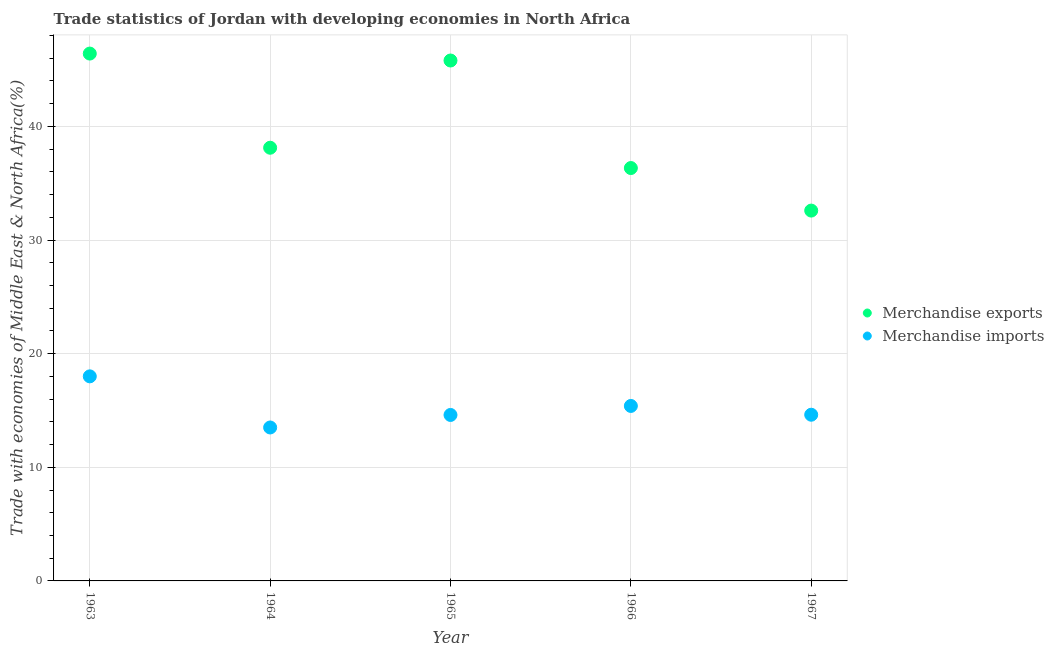How many different coloured dotlines are there?
Your answer should be compact. 2. What is the merchandise imports in 1963?
Provide a succinct answer. 18. Across all years, what is the maximum merchandise imports?
Make the answer very short. 18. Across all years, what is the minimum merchandise imports?
Offer a very short reply. 13.5. In which year was the merchandise imports minimum?
Provide a succinct answer. 1964. What is the total merchandise exports in the graph?
Your answer should be very brief. 199.24. What is the difference between the merchandise exports in 1965 and that in 1967?
Provide a short and direct response. 13.21. What is the difference between the merchandise exports in 1965 and the merchandise imports in 1967?
Make the answer very short. 31.17. What is the average merchandise imports per year?
Offer a very short reply. 15.23. In the year 1963, what is the difference between the merchandise imports and merchandise exports?
Provide a short and direct response. -28.4. In how many years, is the merchandise imports greater than 22 %?
Your answer should be compact. 0. What is the ratio of the merchandise exports in 1963 to that in 1967?
Your response must be concise. 1.42. What is the difference between the highest and the second highest merchandise exports?
Ensure brevity in your answer.  0.61. What is the difference between the highest and the lowest merchandise exports?
Offer a terse response. 13.82. Is the merchandise imports strictly greater than the merchandise exports over the years?
Offer a terse response. No. What is the difference between two consecutive major ticks on the Y-axis?
Ensure brevity in your answer.  10. Are the values on the major ticks of Y-axis written in scientific E-notation?
Ensure brevity in your answer.  No. Does the graph contain grids?
Offer a very short reply. Yes. How are the legend labels stacked?
Your response must be concise. Vertical. What is the title of the graph?
Keep it short and to the point. Trade statistics of Jordan with developing economies in North Africa. Does "Males" appear as one of the legend labels in the graph?
Your response must be concise. No. What is the label or title of the X-axis?
Give a very brief answer. Year. What is the label or title of the Y-axis?
Make the answer very short. Trade with economies of Middle East & North Africa(%). What is the Trade with economies of Middle East & North Africa(%) in Merchandise exports in 1963?
Your answer should be very brief. 46.41. What is the Trade with economies of Middle East & North Africa(%) in Merchandise imports in 1963?
Make the answer very short. 18. What is the Trade with economies of Middle East & North Africa(%) in Merchandise exports in 1964?
Make the answer very short. 38.12. What is the Trade with economies of Middle East & North Africa(%) of Merchandise imports in 1964?
Your answer should be compact. 13.5. What is the Trade with economies of Middle East & North Africa(%) of Merchandise exports in 1965?
Keep it short and to the point. 45.79. What is the Trade with economies of Middle East & North Africa(%) in Merchandise imports in 1965?
Offer a terse response. 14.6. What is the Trade with economies of Middle East & North Africa(%) of Merchandise exports in 1966?
Offer a terse response. 36.33. What is the Trade with economies of Middle East & North Africa(%) of Merchandise imports in 1966?
Your answer should be compact. 15.4. What is the Trade with economies of Middle East & North Africa(%) of Merchandise exports in 1967?
Offer a terse response. 32.59. What is the Trade with economies of Middle East & North Africa(%) of Merchandise imports in 1967?
Ensure brevity in your answer.  14.62. Across all years, what is the maximum Trade with economies of Middle East & North Africa(%) of Merchandise exports?
Keep it short and to the point. 46.41. Across all years, what is the maximum Trade with economies of Middle East & North Africa(%) in Merchandise imports?
Provide a short and direct response. 18. Across all years, what is the minimum Trade with economies of Middle East & North Africa(%) of Merchandise exports?
Your answer should be compact. 32.59. Across all years, what is the minimum Trade with economies of Middle East & North Africa(%) of Merchandise imports?
Offer a terse response. 13.5. What is the total Trade with economies of Middle East & North Africa(%) in Merchandise exports in the graph?
Your response must be concise. 199.24. What is the total Trade with economies of Middle East & North Africa(%) of Merchandise imports in the graph?
Keep it short and to the point. 76.13. What is the difference between the Trade with economies of Middle East & North Africa(%) in Merchandise exports in 1963 and that in 1964?
Your response must be concise. 8.29. What is the difference between the Trade with economies of Middle East & North Africa(%) of Merchandise imports in 1963 and that in 1964?
Offer a terse response. 4.5. What is the difference between the Trade with economies of Middle East & North Africa(%) in Merchandise exports in 1963 and that in 1965?
Offer a very short reply. 0.61. What is the difference between the Trade with economies of Middle East & North Africa(%) of Merchandise imports in 1963 and that in 1965?
Give a very brief answer. 3.4. What is the difference between the Trade with economies of Middle East & North Africa(%) in Merchandise exports in 1963 and that in 1966?
Offer a terse response. 10.07. What is the difference between the Trade with economies of Middle East & North Africa(%) of Merchandise imports in 1963 and that in 1966?
Provide a succinct answer. 2.6. What is the difference between the Trade with economies of Middle East & North Africa(%) of Merchandise exports in 1963 and that in 1967?
Your answer should be very brief. 13.82. What is the difference between the Trade with economies of Middle East & North Africa(%) in Merchandise imports in 1963 and that in 1967?
Your answer should be compact. 3.38. What is the difference between the Trade with economies of Middle East & North Africa(%) in Merchandise exports in 1964 and that in 1965?
Keep it short and to the point. -7.68. What is the difference between the Trade with economies of Middle East & North Africa(%) in Merchandise imports in 1964 and that in 1965?
Offer a very short reply. -1.1. What is the difference between the Trade with economies of Middle East & North Africa(%) of Merchandise exports in 1964 and that in 1966?
Your answer should be compact. 1.79. What is the difference between the Trade with economies of Middle East & North Africa(%) of Merchandise imports in 1964 and that in 1966?
Ensure brevity in your answer.  -1.89. What is the difference between the Trade with economies of Middle East & North Africa(%) of Merchandise exports in 1964 and that in 1967?
Make the answer very short. 5.53. What is the difference between the Trade with economies of Middle East & North Africa(%) in Merchandise imports in 1964 and that in 1967?
Make the answer very short. -1.12. What is the difference between the Trade with economies of Middle East & North Africa(%) of Merchandise exports in 1965 and that in 1966?
Provide a short and direct response. 9.46. What is the difference between the Trade with economies of Middle East & North Africa(%) in Merchandise imports in 1965 and that in 1966?
Offer a very short reply. -0.79. What is the difference between the Trade with economies of Middle East & North Africa(%) in Merchandise exports in 1965 and that in 1967?
Make the answer very short. 13.21. What is the difference between the Trade with economies of Middle East & North Africa(%) of Merchandise imports in 1965 and that in 1967?
Your answer should be very brief. -0.02. What is the difference between the Trade with economies of Middle East & North Africa(%) in Merchandise exports in 1966 and that in 1967?
Provide a succinct answer. 3.74. What is the difference between the Trade with economies of Middle East & North Africa(%) in Merchandise imports in 1966 and that in 1967?
Offer a very short reply. 0.77. What is the difference between the Trade with economies of Middle East & North Africa(%) of Merchandise exports in 1963 and the Trade with economies of Middle East & North Africa(%) of Merchandise imports in 1964?
Your response must be concise. 32.9. What is the difference between the Trade with economies of Middle East & North Africa(%) of Merchandise exports in 1963 and the Trade with economies of Middle East & North Africa(%) of Merchandise imports in 1965?
Offer a terse response. 31.8. What is the difference between the Trade with economies of Middle East & North Africa(%) in Merchandise exports in 1963 and the Trade with economies of Middle East & North Africa(%) in Merchandise imports in 1966?
Your answer should be very brief. 31.01. What is the difference between the Trade with economies of Middle East & North Africa(%) of Merchandise exports in 1963 and the Trade with economies of Middle East & North Africa(%) of Merchandise imports in 1967?
Keep it short and to the point. 31.78. What is the difference between the Trade with economies of Middle East & North Africa(%) of Merchandise exports in 1964 and the Trade with economies of Middle East & North Africa(%) of Merchandise imports in 1965?
Your answer should be compact. 23.51. What is the difference between the Trade with economies of Middle East & North Africa(%) in Merchandise exports in 1964 and the Trade with economies of Middle East & North Africa(%) in Merchandise imports in 1966?
Make the answer very short. 22.72. What is the difference between the Trade with economies of Middle East & North Africa(%) in Merchandise exports in 1964 and the Trade with economies of Middle East & North Africa(%) in Merchandise imports in 1967?
Keep it short and to the point. 23.49. What is the difference between the Trade with economies of Middle East & North Africa(%) in Merchandise exports in 1965 and the Trade with economies of Middle East & North Africa(%) in Merchandise imports in 1966?
Keep it short and to the point. 30.4. What is the difference between the Trade with economies of Middle East & North Africa(%) in Merchandise exports in 1965 and the Trade with economies of Middle East & North Africa(%) in Merchandise imports in 1967?
Keep it short and to the point. 31.17. What is the difference between the Trade with economies of Middle East & North Africa(%) in Merchandise exports in 1966 and the Trade with economies of Middle East & North Africa(%) in Merchandise imports in 1967?
Give a very brief answer. 21.71. What is the average Trade with economies of Middle East & North Africa(%) of Merchandise exports per year?
Offer a very short reply. 39.85. What is the average Trade with economies of Middle East & North Africa(%) of Merchandise imports per year?
Your answer should be compact. 15.23. In the year 1963, what is the difference between the Trade with economies of Middle East & North Africa(%) of Merchandise exports and Trade with economies of Middle East & North Africa(%) of Merchandise imports?
Offer a terse response. 28.4. In the year 1964, what is the difference between the Trade with economies of Middle East & North Africa(%) in Merchandise exports and Trade with economies of Middle East & North Africa(%) in Merchandise imports?
Ensure brevity in your answer.  24.62. In the year 1965, what is the difference between the Trade with economies of Middle East & North Africa(%) of Merchandise exports and Trade with economies of Middle East & North Africa(%) of Merchandise imports?
Offer a terse response. 31.19. In the year 1966, what is the difference between the Trade with economies of Middle East & North Africa(%) of Merchandise exports and Trade with economies of Middle East & North Africa(%) of Merchandise imports?
Provide a succinct answer. 20.94. In the year 1967, what is the difference between the Trade with economies of Middle East & North Africa(%) of Merchandise exports and Trade with economies of Middle East & North Africa(%) of Merchandise imports?
Provide a succinct answer. 17.96. What is the ratio of the Trade with economies of Middle East & North Africa(%) of Merchandise exports in 1963 to that in 1964?
Offer a terse response. 1.22. What is the ratio of the Trade with economies of Middle East & North Africa(%) in Merchandise imports in 1963 to that in 1964?
Offer a terse response. 1.33. What is the ratio of the Trade with economies of Middle East & North Africa(%) of Merchandise exports in 1963 to that in 1965?
Your response must be concise. 1.01. What is the ratio of the Trade with economies of Middle East & North Africa(%) of Merchandise imports in 1963 to that in 1965?
Offer a terse response. 1.23. What is the ratio of the Trade with economies of Middle East & North Africa(%) of Merchandise exports in 1963 to that in 1966?
Your response must be concise. 1.28. What is the ratio of the Trade with economies of Middle East & North Africa(%) in Merchandise imports in 1963 to that in 1966?
Ensure brevity in your answer.  1.17. What is the ratio of the Trade with economies of Middle East & North Africa(%) in Merchandise exports in 1963 to that in 1967?
Your response must be concise. 1.42. What is the ratio of the Trade with economies of Middle East & North Africa(%) in Merchandise imports in 1963 to that in 1967?
Make the answer very short. 1.23. What is the ratio of the Trade with economies of Middle East & North Africa(%) of Merchandise exports in 1964 to that in 1965?
Your response must be concise. 0.83. What is the ratio of the Trade with economies of Middle East & North Africa(%) in Merchandise imports in 1964 to that in 1965?
Give a very brief answer. 0.92. What is the ratio of the Trade with economies of Middle East & North Africa(%) of Merchandise exports in 1964 to that in 1966?
Provide a short and direct response. 1.05. What is the ratio of the Trade with economies of Middle East & North Africa(%) of Merchandise imports in 1964 to that in 1966?
Offer a very short reply. 0.88. What is the ratio of the Trade with economies of Middle East & North Africa(%) in Merchandise exports in 1964 to that in 1967?
Your answer should be compact. 1.17. What is the ratio of the Trade with economies of Middle East & North Africa(%) of Merchandise imports in 1964 to that in 1967?
Keep it short and to the point. 0.92. What is the ratio of the Trade with economies of Middle East & North Africa(%) in Merchandise exports in 1965 to that in 1966?
Provide a succinct answer. 1.26. What is the ratio of the Trade with economies of Middle East & North Africa(%) of Merchandise imports in 1965 to that in 1966?
Provide a succinct answer. 0.95. What is the ratio of the Trade with economies of Middle East & North Africa(%) of Merchandise exports in 1965 to that in 1967?
Give a very brief answer. 1.41. What is the ratio of the Trade with economies of Middle East & North Africa(%) in Merchandise imports in 1965 to that in 1967?
Keep it short and to the point. 1. What is the ratio of the Trade with economies of Middle East & North Africa(%) of Merchandise exports in 1966 to that in 1967?
Offer a very short reply. 1.11. What is the ratio of the Trade with economies of Middle East & North Africa(%) of Merchandise imports in 1966 to that in 1967?
Your response must be concise. 1.05. What is the difference between the highest and the second highest Trade with economies of Middle East & North Africa(%) in Merchandise exports?
Keep it short and to the point. 0.61. What is the difference between the highest and the second highest Trade with economies of Middle East & North Africa(%) in Merchandise imports?
Keep it short and to the point. 2.6. What is the difference between the highest and the lowest Trade with economies of Middle East & North Africa(%) of Merchandise exports?
Make the answer very short. 13.82. What is the difference between the highest and the lowest Trade with economies of Middle East & North Africa(%) in Merchandise imports?
Make the answer very short. 4.5. 